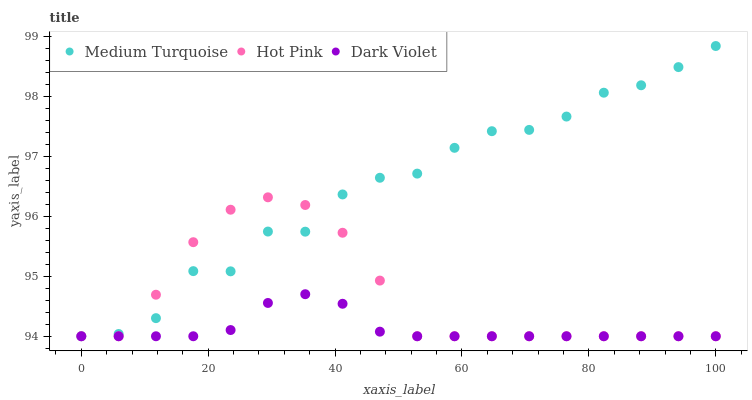Does Dark Violet have the minimum area under the curve?
Answer yes or no. Yes. Does Medium Turquoise have the maximum area under the curve?
Answer yes or no. Yes. Does Medium Turquoise have the minimum area under the curve?
Answer yes or no. No. Does Dark Violet have the maximum area under the curve?
Answer yes or no. No. Is Dark Violet the smoothest?
Answer yes or no. Yes. Is Medium Turquoise the roughest?
Answer yes or no. Yes. Is Medium Turquoise the smoothest?
Answer yes or no. No. Is Dark Violet the roughest?
Answer yes or no. No. Does Hot Pink have the lowest value?
Answer yes or no. Yes. Does Medium Turquoise have the highest value?
Answer yes or no. Yes. Does Dark Violet have the highest value?
Answer yes or no. No. Does Medium Turquoise intersect Hot Pink?
Answer yes or no. Yes. Is Medium Turquoise less than Hot Pink?
Answer yes or no. No. Is Medium Turquoise greater than Hot Pink?
Answer yes or no. No. 